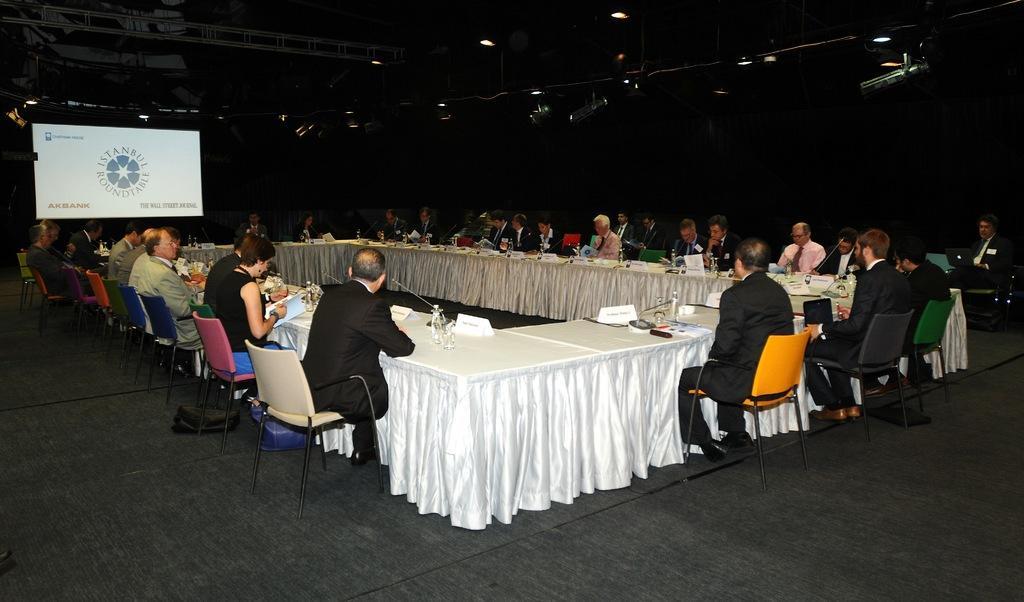Please provide a concise description of this image. In this image i can see group of people sitting on chairs in front of a table, and on a table i can see bottles and microphones. In the background i can see screens and some pillars and dome lights. 